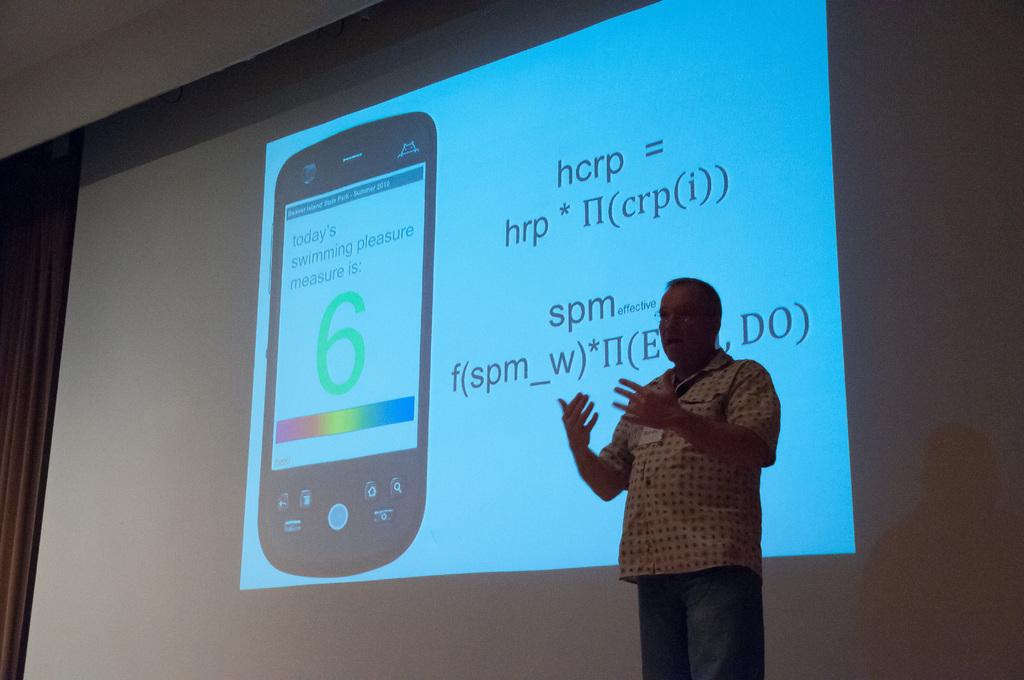What green number is on the screen of that phone?
Keep it short and to the point. 6. 